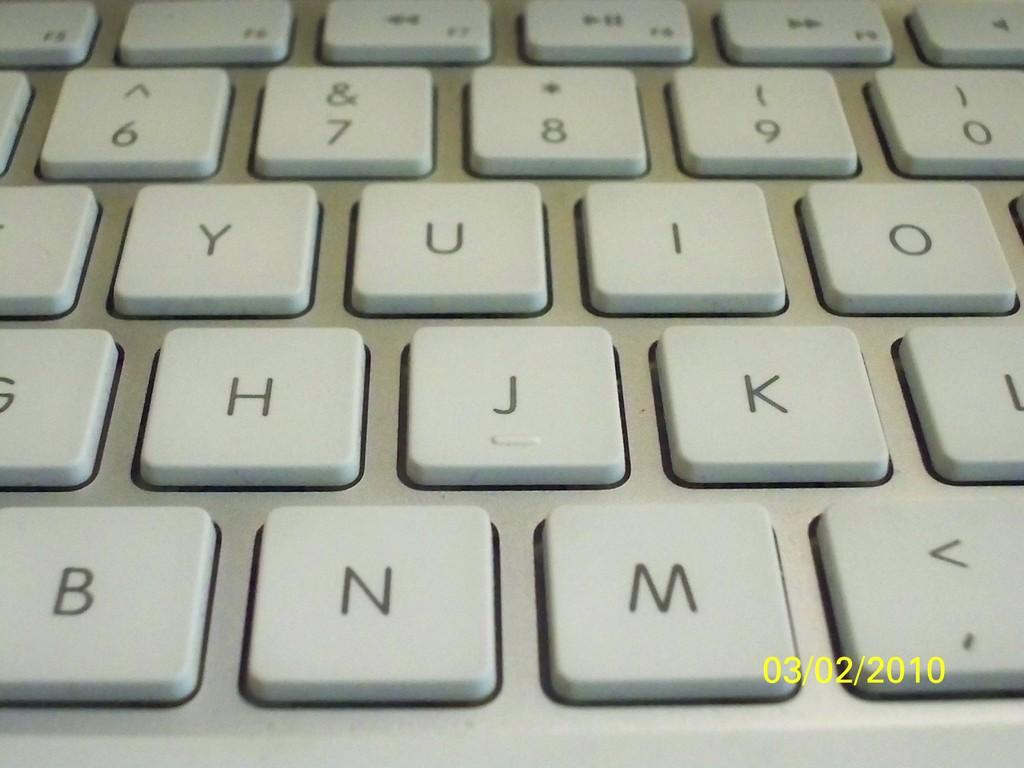Provide a one-sentence caption for the provided image. The letter N is to the left of the letter M. 